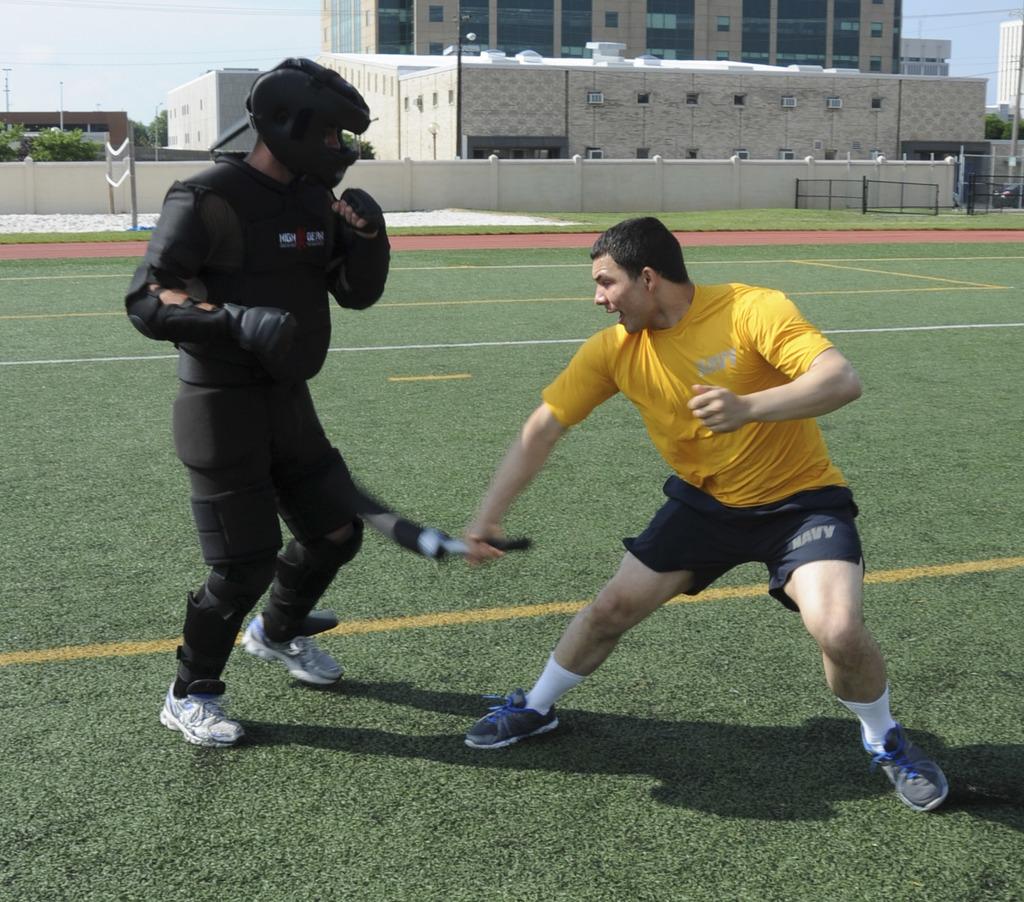What branch of military does his shorts say?
Offer a terse response. Navy. 